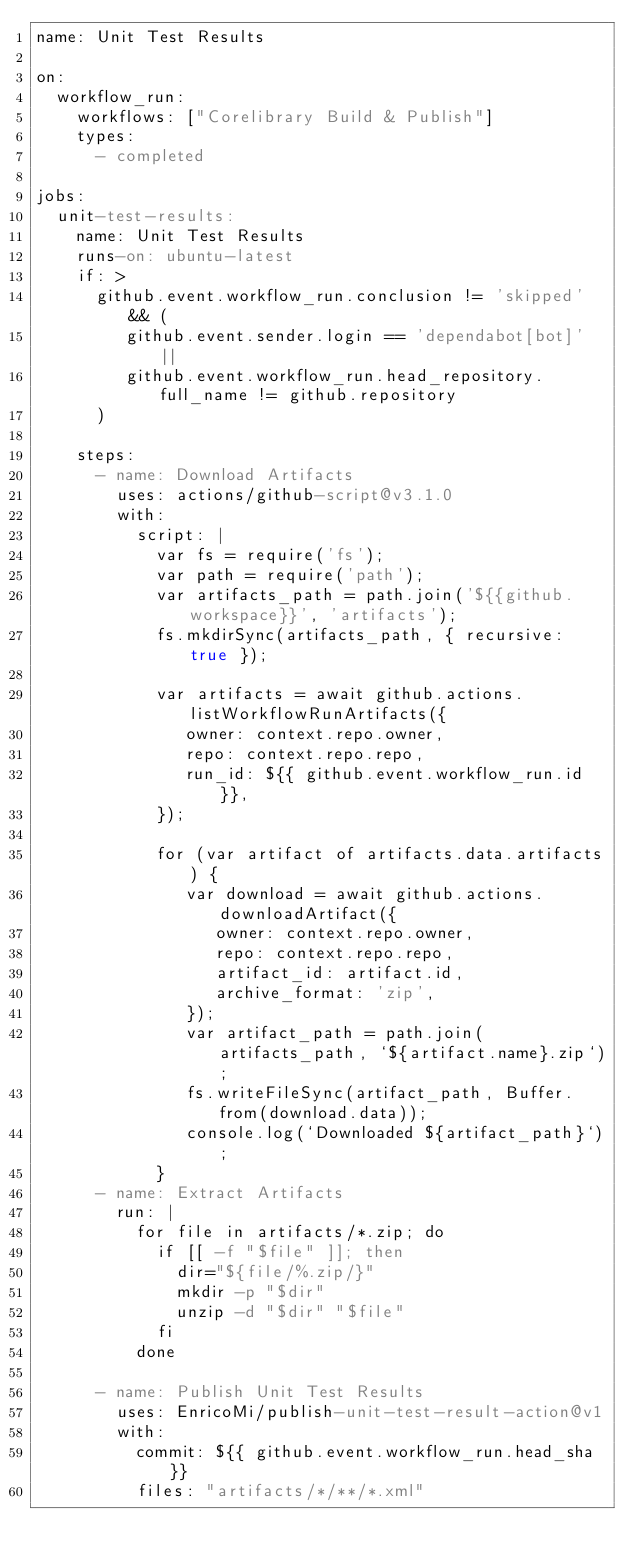<code> <loc_0><loc_0><loc_500><loc_500><_YAML_>name: Unit Test Results

on:
  workflow_run:
    workflows: ["Corelibrary Build & Publish"]
    types:
      - completed

jobs:
  unit-test-results:
    name: Unit Test Results
    runs-on: ubuntu-latest
    if: >
      github.event.workflow_run.conclusion != 'skipped' && (
         github.event.sender.login == 'dependabot[bot]' ||
         github.event.workflow_run.head_repository.full_name != github.repository
      )

    steps:
      - name: Download Artifacts
        uses: actions/github-script@v3.1.0
        with:
          script: |
            var fs = require('fs');
            var path = require('path');
            var artifacts_path = path.join('${{github.workspace}}', 'artifacts');
            fs.mkdirSync(artifacts_path, { recursive: true });

            var artifacts = await github.actions.listWorkflowRunArtifacts({
               owner: context.repo.owner,
               repo: context.repo.repo,
               run_id: ${{ github.event.workflow_run.id }},
            });

            for (var artifact of artifacts.data.artifacts) {
               var download = await github.actions.downloadArtifact({
                  owner: context.repo.owner,
                  repo: context.repo.repo,
                  artifact_id: artifact.id,
                  archive_format: 'zip',
               });
               var artifact_path = path.join(artifacts_path, `${artifact.name}.zip`);
               fs.writeFileSync(artifact_path, Buffer.from(download.data));
               console.log(`Downloaded ${artifact_path}`);
            }
      - name: Extract Artifacts
        run: |
          for file in artifacts/*.zip; do
            if [[ -f "$file" ]]; then
              dir="${file/%.zip/}"
              mkdir -p "$dir"
              unzip -d "$dir" "$file"
            fi
          done

      - name: Publish Unit Test Results
        uses: EnricoMi/publish-unit-test-result-action@v1
        with:
          commit: ${{ github.event.workflow_run.head_sha }}
          files: "artifacts/*/**/*.xml"
</code> 